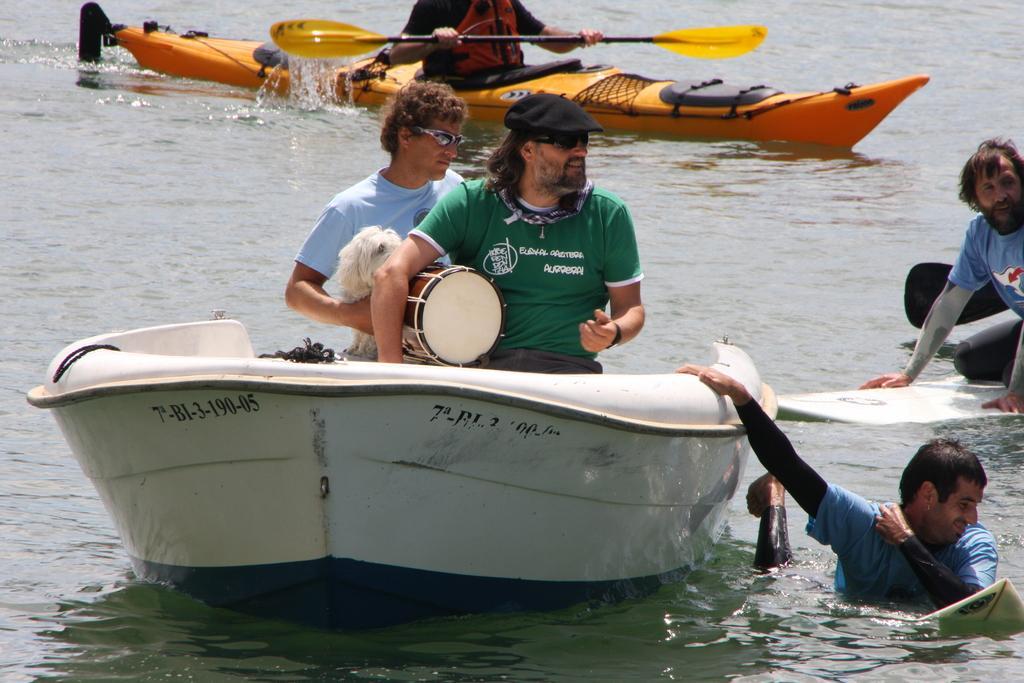In one or two sentences, can you explain what this image depicts? Here in this picture we can see a white board in the water. In that whiteboard there are two persons sitting on it. We can see a drum. And in the water there are two persons. And in the orange color board there is a person. 